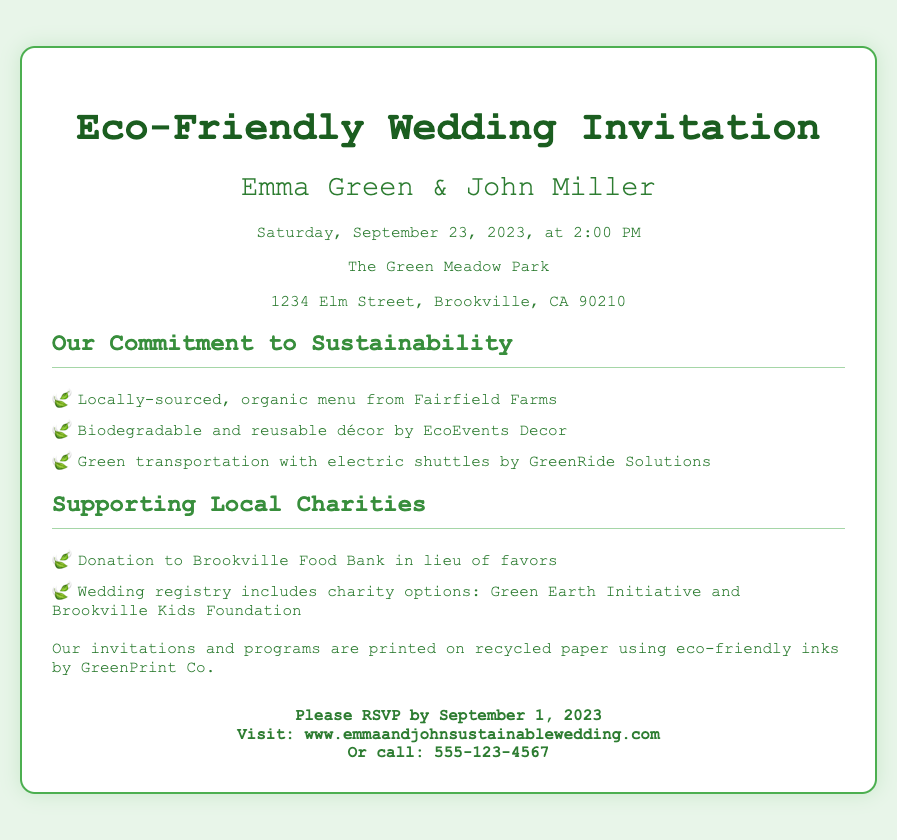What are the names of the couple? The names of the couple are listed prominently at the top of the invitation.
Answer: Emma Green & John Miller When is the wedding date? The wedding date is mentioned in the date-time section of the invitation.
Answer: Saturday, September 23, 2023 What type of menu will be served? The type of menu is detailed under the commitment to sustainability section.
Answer: Locally-sourced, organic menu Where is the venue located? The venue information provides the location details.
Answer: The Green Meadow Park What alternative is mentioned instead of wedding favors? The mention of donations in lieu of favors is found in the supporting local charities section.
Answer: Donation to Brookville Food Bank What company is handling the décor? The decorating company is specified in the sustainability section.
Answer: EcoEvents Decor What is the RSVP deadline? The RSVP deadline is stated at the bottom of the invitation.
Answer: September 1, 2023 How can guests RSVP? This information is included in the RSVP section.
Answer: www.emmaandjohnsustainablewedding.com 